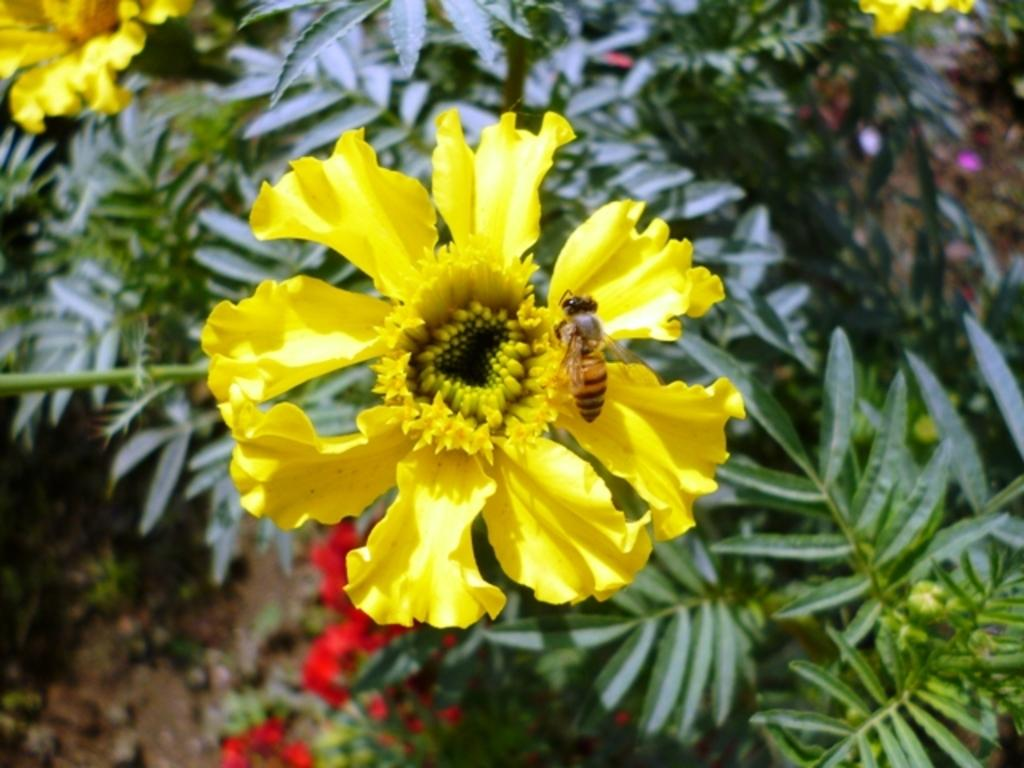What type of flower is in the image? There is a yellow flower in the image. Is the flower part of a larger plant? Yes, the flower is part of a plant. What can be seen on the plant in the image? There is a honey bee on the plant in the image. How does the plant heal its wound in the image? There is no indication of a wound on the plant in the image, so it cannot be determined how the plant would heal it. 